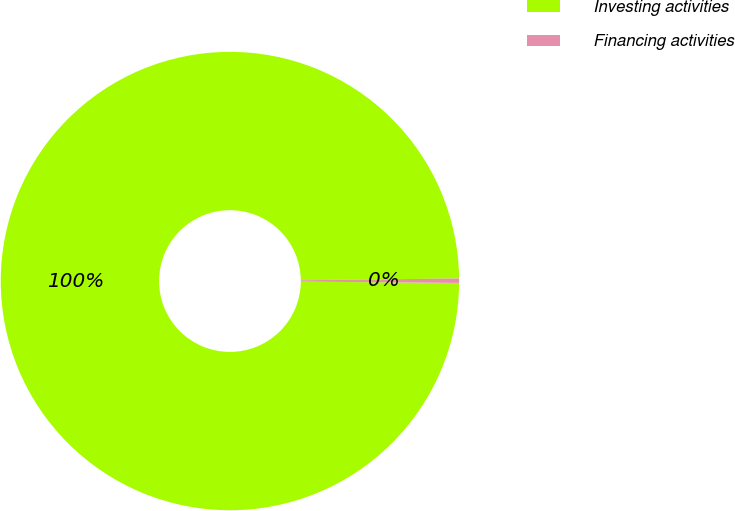<chart> <loc_0><loc_0><loc_500><loc_500><pie_chart><fcel>Investing activities<fcel>Financing activities<nl><fcel>99.69%<fcel>0.31%<nl></chart> 